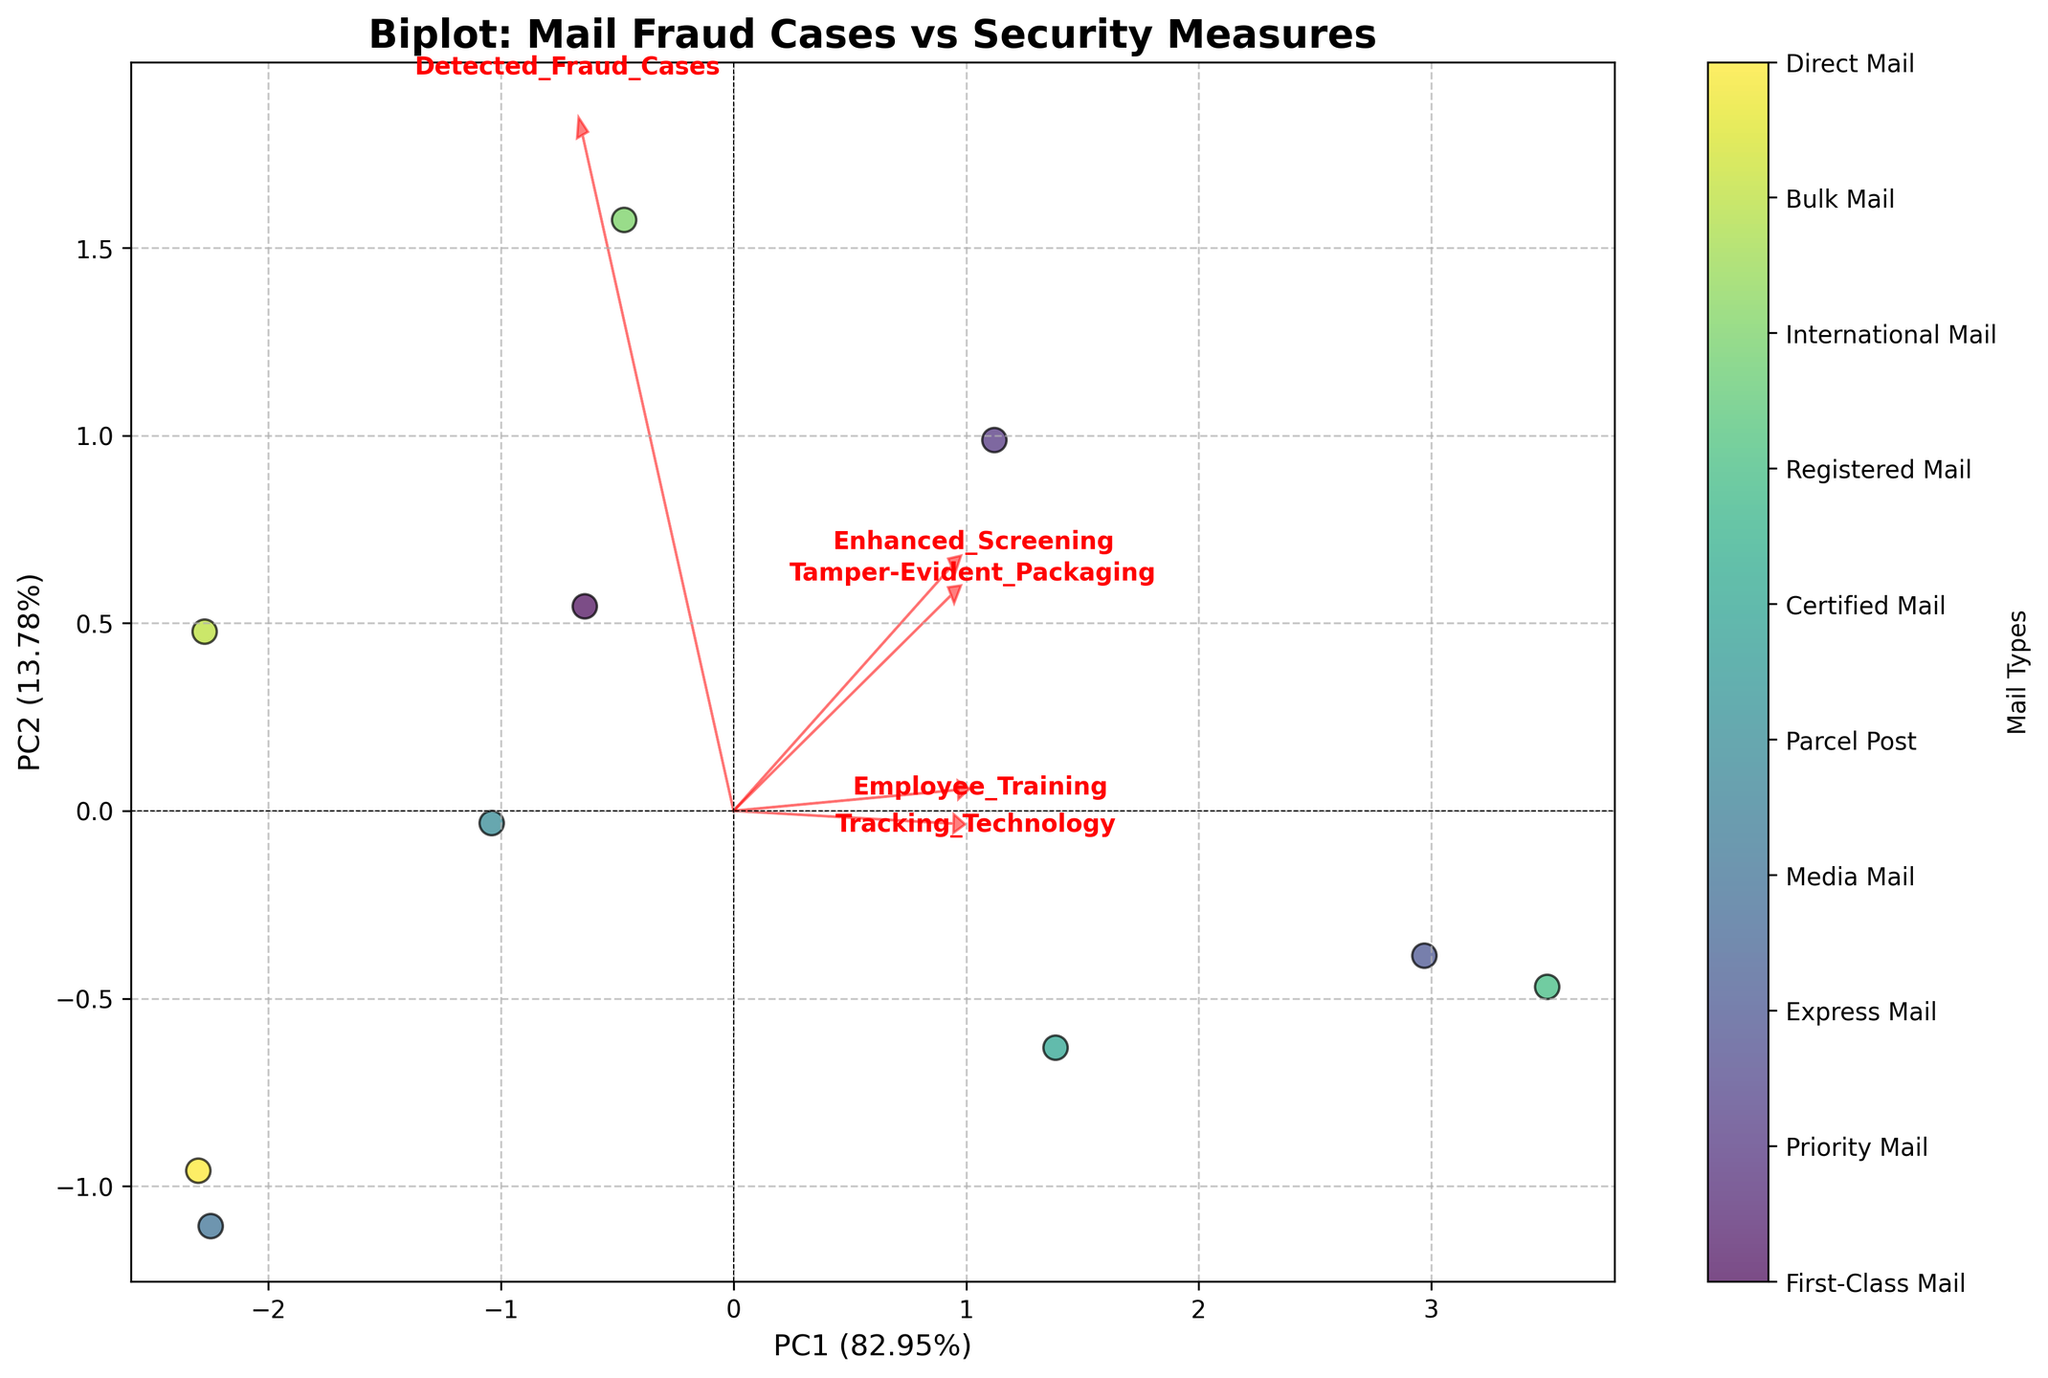What is the title of the plot? The title is usually located at the top of the plot. Reading it directly gives us the insight.
Answer: Biplot: Mail Fraud Cases vs Security Measures How are the mail types represented in the plot? The mail types are represented by various colored points on the plot. Each point corresponds to a different type of mail.
Answer: Colored points Which two principal components are shown on the axes? The axes are labeled with the principal components. The x-axis is typically labeled as 'PC1' and the y-axis as 'PC2'.
Answer: PC1 and PC2 How many security measures are displayed with arrows? By counting the arrows on the plot, we can see how many security measures are represented.
Answer: Five Which mail type has the highest detected fraud cases? Refer to the color bar on the plot to see which colored point corresponds to the mail type with the highest detected fraud cases.
Answer: International Mail Which principal component explains more variance? Look at the percentage of variance explained in the axis labels. The one with the higher percentage explains more variance.
Answer: PC1 Which mail type seems to be most influenced by enhanced screening? Identify the direction of the arrow representing enhanced screening and find the closest data points.
Answer: Express Mail What is the observed relationship between tracking technology and certified mail? Observe the direction and proximity of the arrows and points for tracking technology and certified mail.
Answer: Strong positive influence What principal component explains the least variance? Compare the percentages of variance explained by PC1 and PC2. The one with the lower percentage explains less variance.
Answer: PC2 Which two mail types are closest to each other in principal component space? Examine the plot and identify the two points that are nearest to each other visually.
Answer: Bulk Mail and Direct Mail 